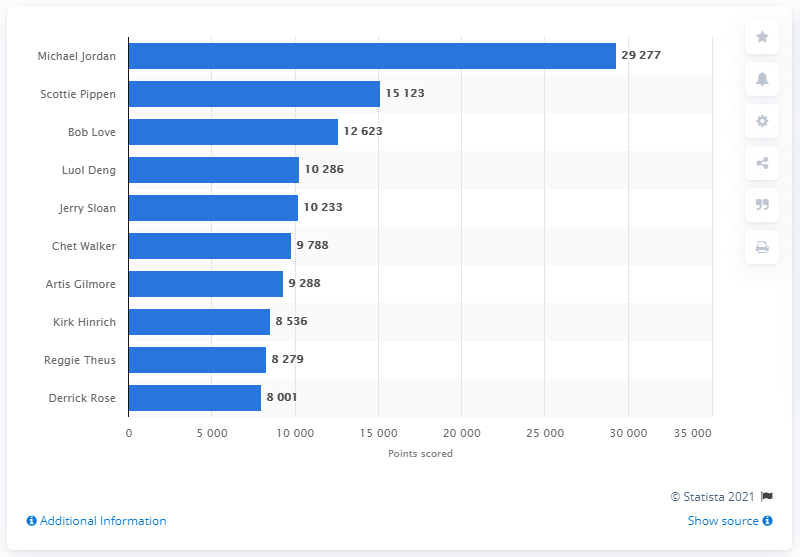Outline some significant characteristics in this image. The career points leader of the Chicago Bulls is Michael Jordan. 